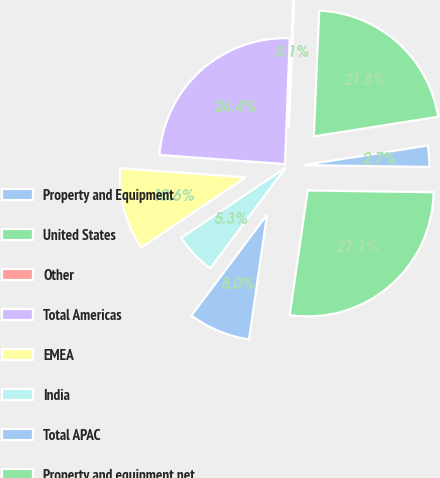Convert chart. <chart><loc_0><loc_0><loc_500><loc_500><pie_chart><fcel>Property and Equipment<fcel>United States<fcel>Other<fcel>Total Americas<fcel>EMEA<fcel>India<fcel>Total APAC<fcel>Property and equipment net<nl><fcel>2.72%<fcel>21.82%<fcel>0.1%<fcel>24.44%<fcel>10.58%<fcel>5.34%<fcel>7.96%<fcel>27.06%<nl></chart> 